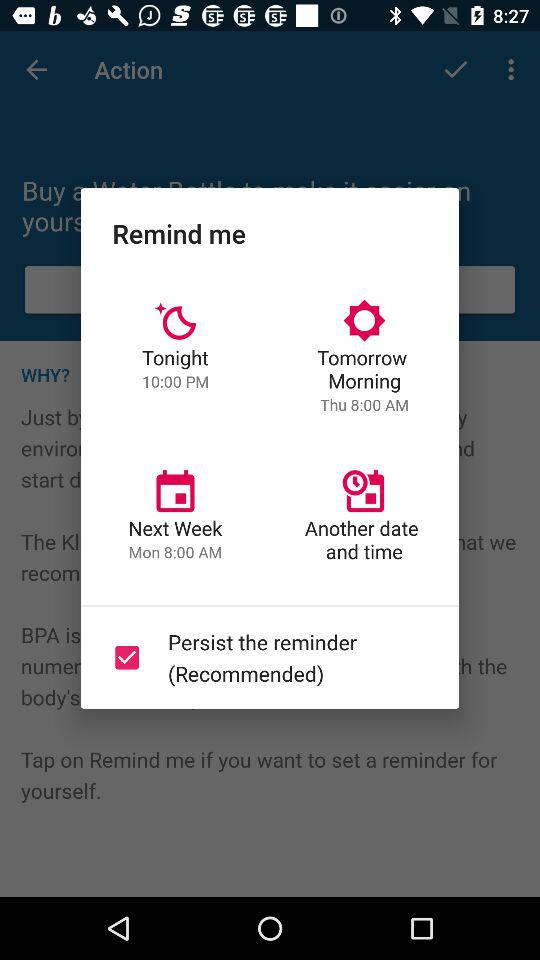How many reminder times are available?
Answer the question using a single word or phrase. 4 